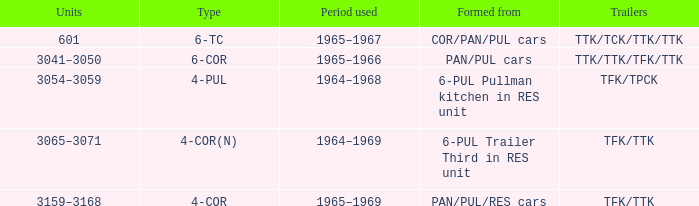Name the typed for formed from 6-pul trailer third in res unit 4-COR(N). 